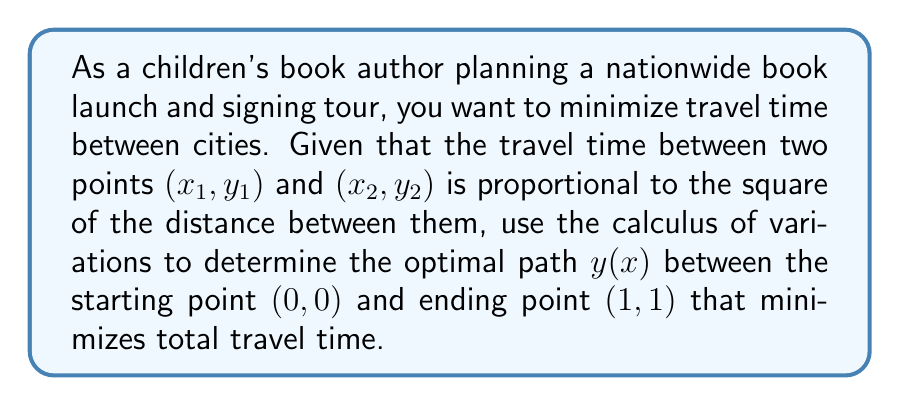Can you solve this math problem? To solve this problem, we'll use the Euler-Lagrange equation from the calculus of variations.

1. First, we need to set up our functional. The travel time between two infinitesimally close points is proportional to the square of the distance:

   $$dT \propto ds^2 = dx^2 + dy^2 = (1 + y'^2)dx^2$$

2. Our functional to minimize is:

   $$T[y] = \int_0^1 (1 + y'^2) dx$$

3. The Euler-Lagrange equation is:

   $$\frac{\partial F}{\partial y} - \frac{d}{dx}\left(\frac{\partial F}{\partial y'}\right) = 0$$

   where $F(x, y, y') = 1 + y'^2$

4. Applying the Euler-Lagrange equation:

   $$\frac{\partial F}{\partial y} = 0$$
   $$\frac{\partial F}{\partial y'} = 2y'$$
   $$\frac{d}{dx}\left(\frac{\partial F}{\partial y'}\right) = 2y''$$

5. Substituting into the Euler-Lagrange equation:

   $$0 - 2y'' = 0$$
   $$y'' = 0$$

6. Solving this differential equation:

   $$y' = C_1$$
   $$y = C_1x + C_2$$

7. Using the boundary conditions $y(0) = 0$ and $y(1) = 1$:

   $$0 = C_2$$
   $$1 = C_1 \cdot 1 + 0$$

   Therefore, $C_1 = 1$ and $C_2 = 0$

8. The optimal path is:

   $$y(x) = x$$

This represents a straight line from $(0, 0)$ to $(1, 1)$.
Answer: The optimal path $y(x)$ that minimizes travel time between $(0, 0)$ and $(1, 1)$ is $y(x) = x$, which is a straight line. 